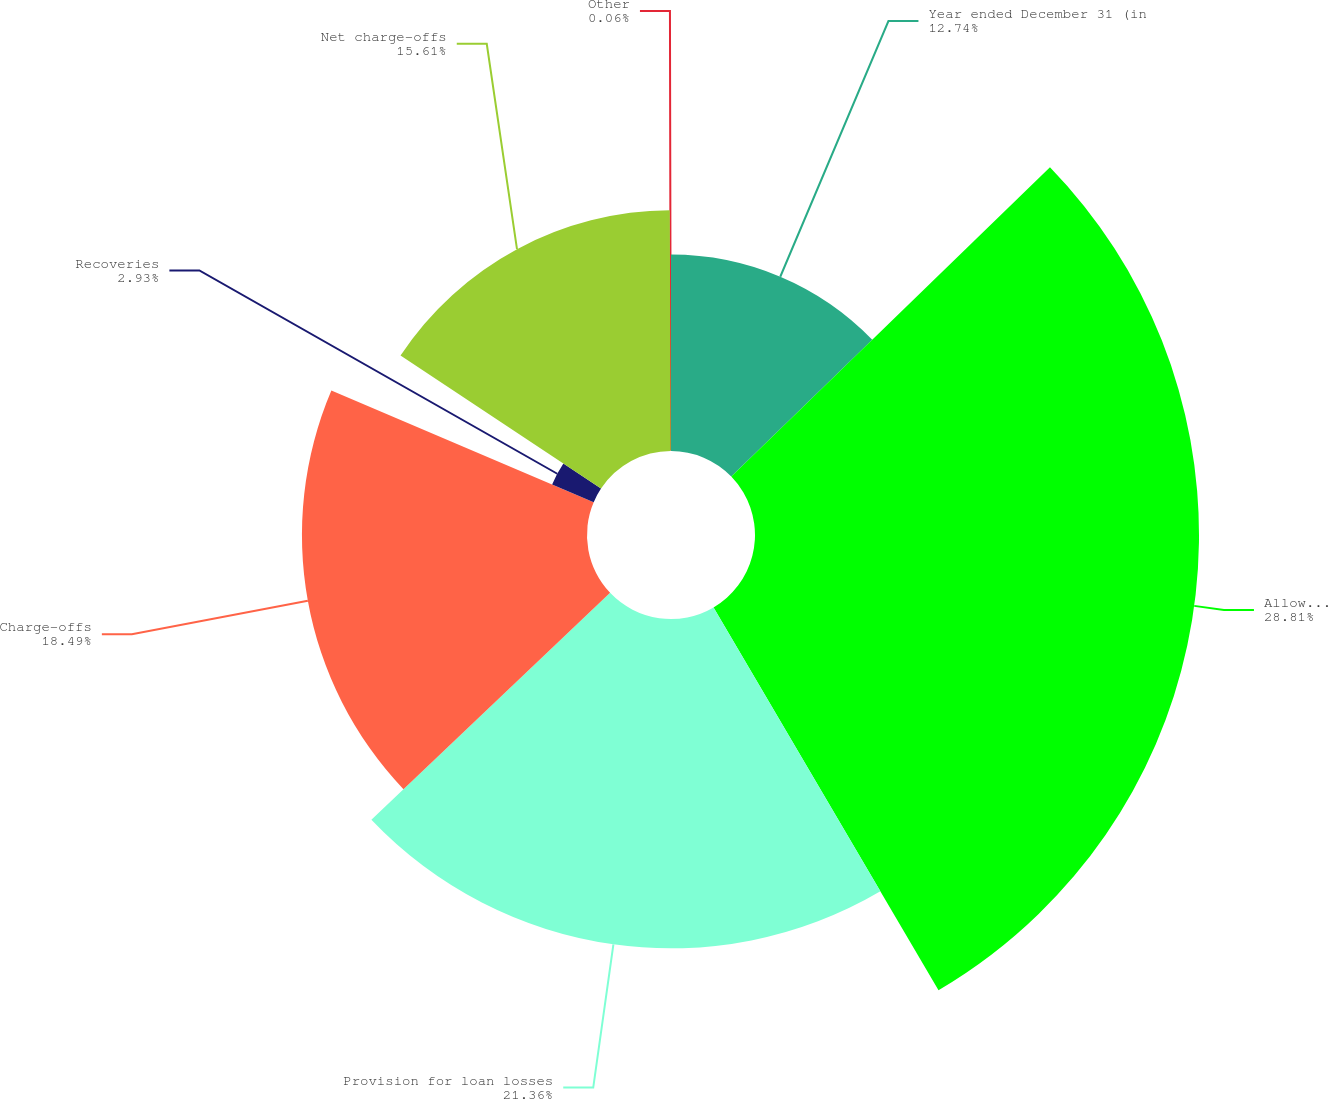Convert chart to OTSL. <chart><loc_0><loc_0><loc_500><loc_500><pie_chart><fcel>Year ended December 31 (in<fcel>Allowance for loan losses at<fcel>Provision for loan losses<fcel>Charge-offs<fcel>Recoveries<fcel>Net charge-offs<fcel>Other<nl><fcel>12.74%<fcel>28.8%<fcel>21.36%<fcel>18.49%<fcel>2.93%<fcel>15.61%<fcel>0.06%<nl></chart> 